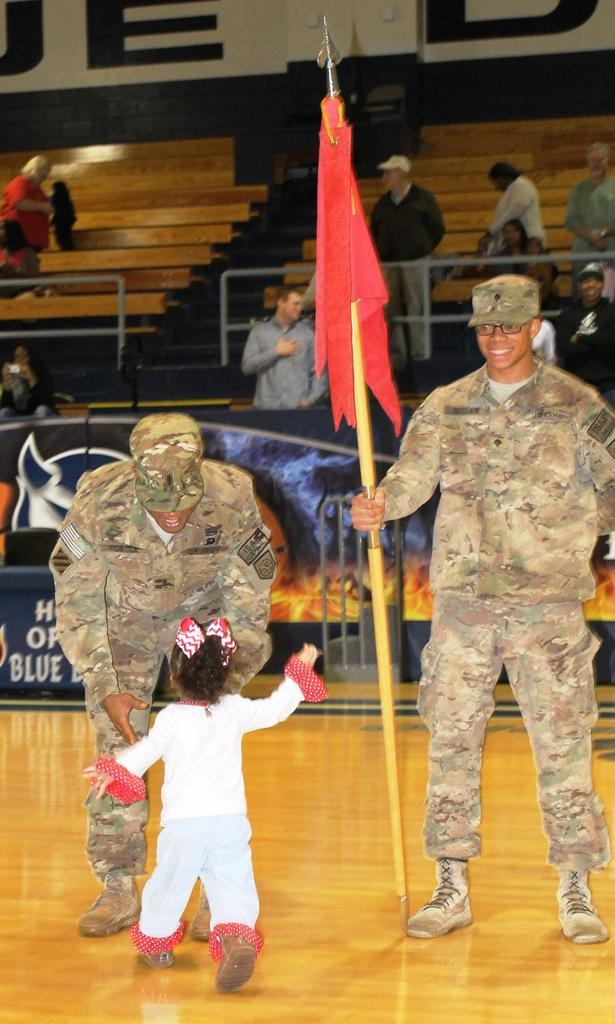How many people are on the floor in the image? There are three people on the floor in the image. What is one person doing with their hands? One person is holding a flag. What can be seen in the background of the image? There is a group of people and objects visible in the background of the image. What type of quill is being used to write on the flag in the image? There is no quill present in the image, and the flag is not being written on. 